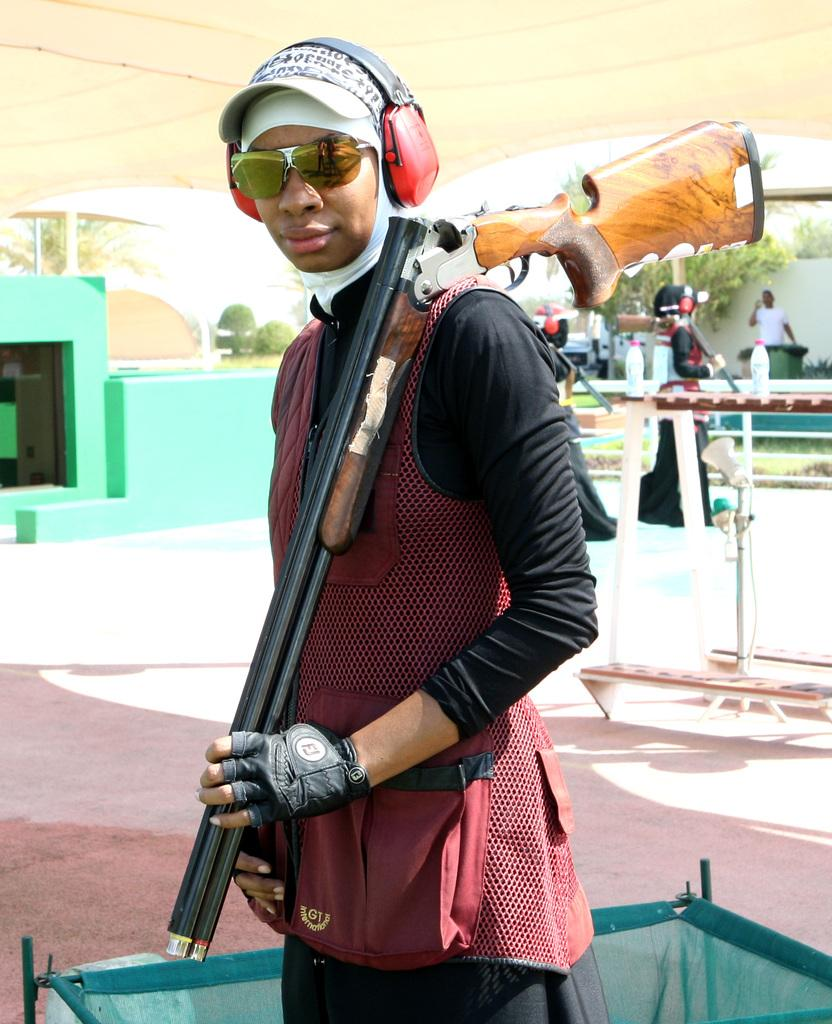What is the person in the image holding? The person is holding a gun. What can be seen on the person's head in the image? The person is wearing a wire headset. What type of eyewear is the person wearing in the image? The person is wearing glasses. Can you describe the background of the image? There are people, trees, plants, and bottles on a surface in the background of the image. What type of drug is the person taking in the image? There is no indication of any drug use in the image; the person is holding a gun and wearing a wire headset and glasses. What pet can be seen playing with the person in the image? There is no pet present in the image. 